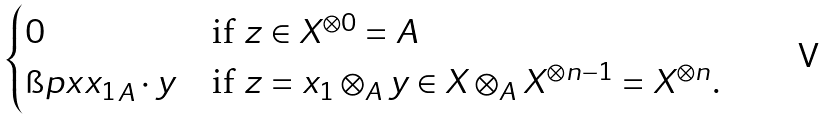Convert formula to latex. <formula><loc_0><loc_0><loc_500><loc_500>\begin{cases} 0 & \text {if $z\in X^{\otimes 0}=A$} \\ \i p { x } { x _ { 1 } } _ { A } \cdot y & \text {if $z=x_{1}\otimes_{A} y\in X\otimes_{A} X^{\otimes n-1}= X^{\otimes n}$.} \\ \end{cases}</formula> 